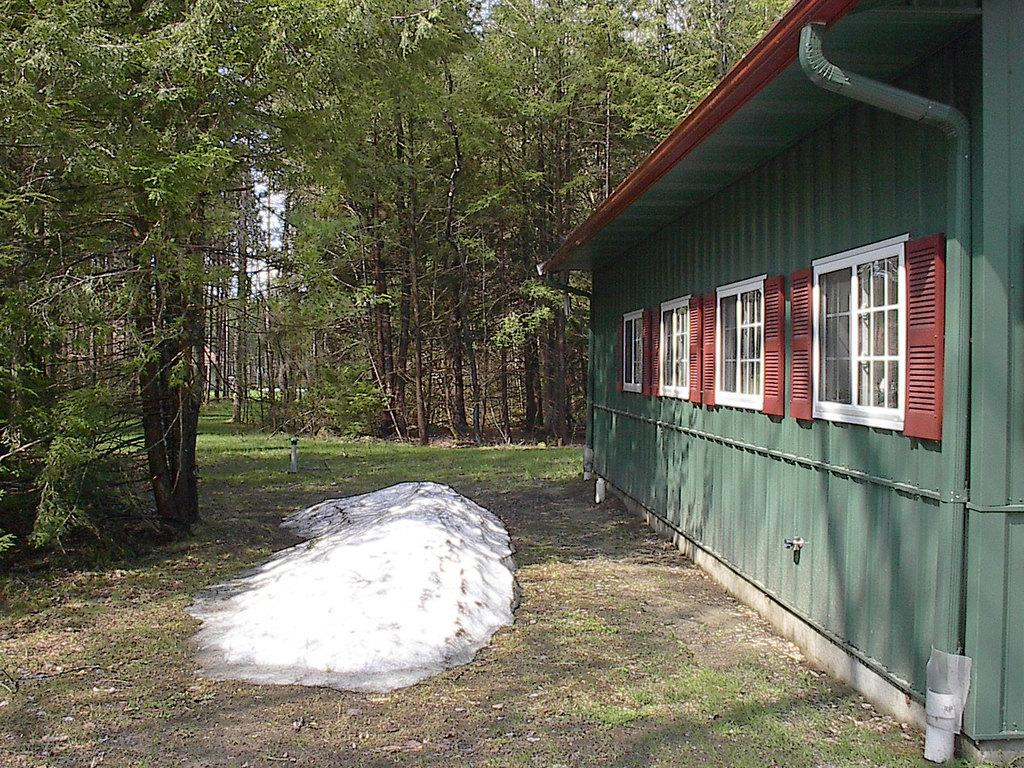What is the main subject of the picture? The main subject of the picture is a house. What specific features can be seen on the house? The house has windows. What other objects or elements are present in the picture? There are trees in the picture. What type of oil can be seen dripping from the wall in the picture? There is no wall or oil present in the picture; it features a house and trees. 